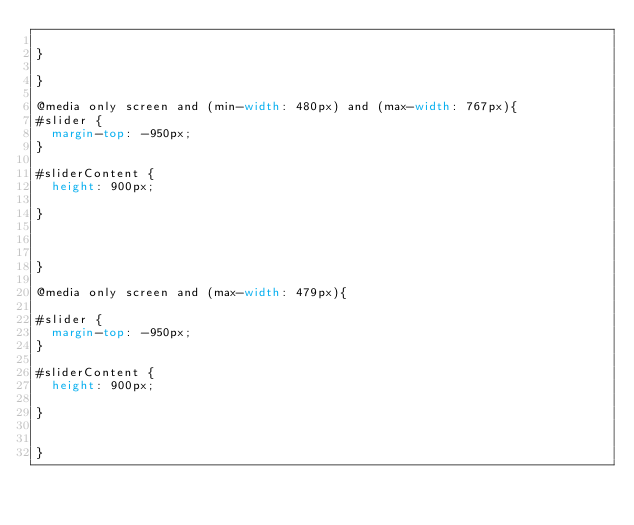<code> <loc_0><loc_0><loc_500><loc_500><_CSS_>	
}

}

@media only screen and (min-width: 480px) and (max-width: 767px){
#slider {
	margin-top: -950px;
}

#sliderContent {
	height: 900px;
	
}


	
}

@media only screen and (max-width: 479px){

#slider {
	margin-top: -950px;
}

#sliderContent {
	height: 900px;
	
}


}



</code> 